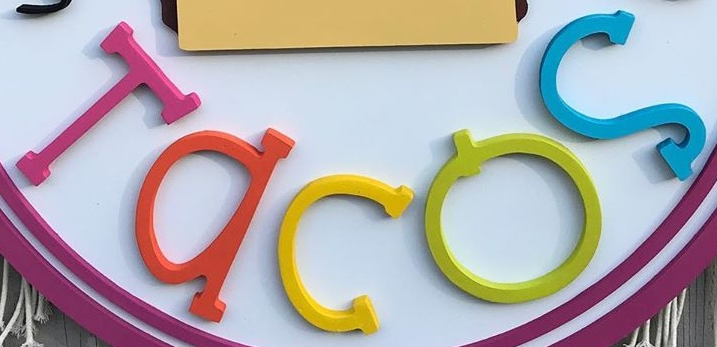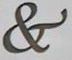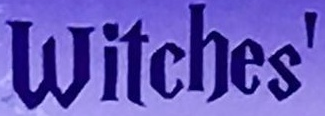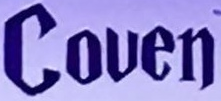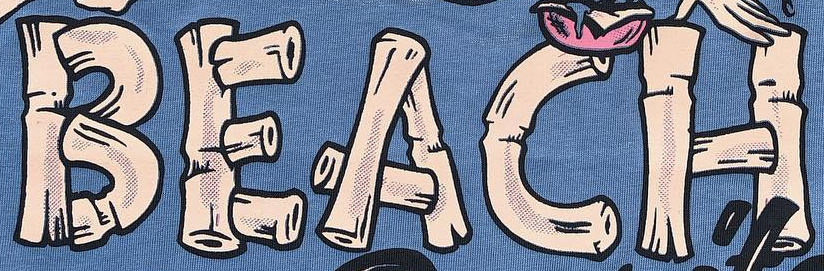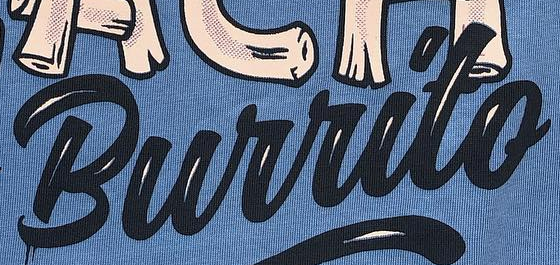Identify the words shown in these images in order, separated by a semicolon. Tacos; &; Witches'; Couen; BEACH; Burrito 